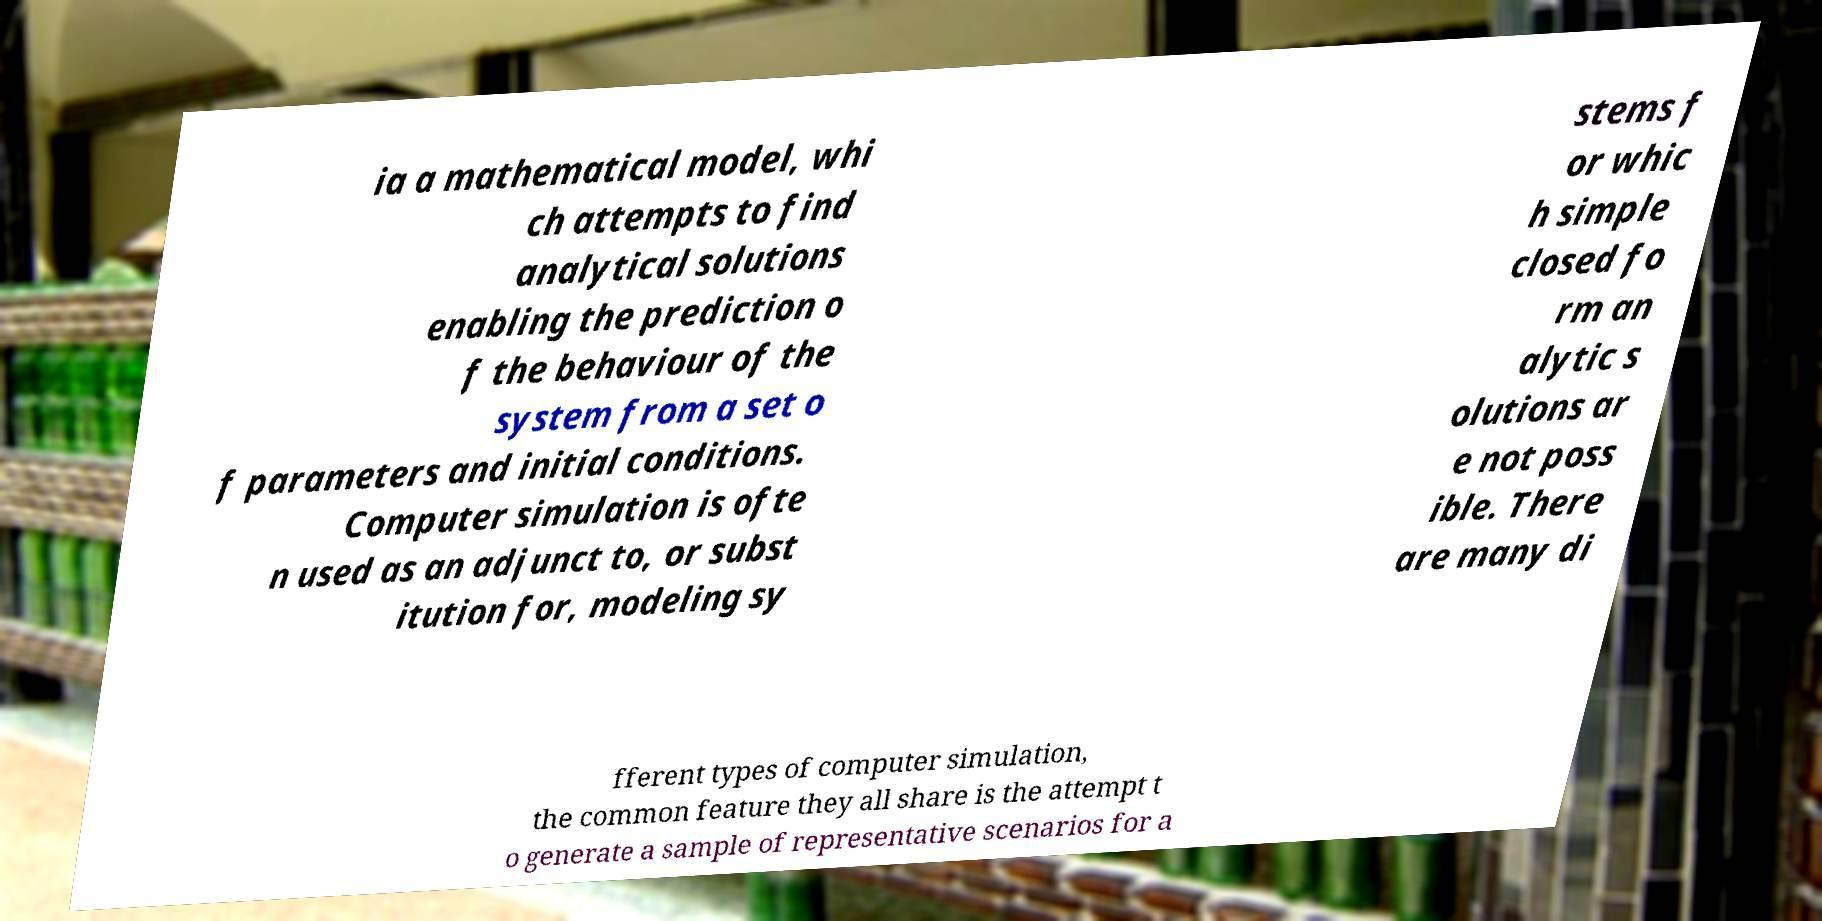Could you extract and type out the text from this image? ia a mathematical model, whi ch attempts to find analytical solutions enabling the prediction o f the behaviour of the system from a set o f parameters and initial conditions. Computer simulation is ofte n used as an adjunct to, or subst itution for, modeling sy stems f or whic h simple closed fo rm an alytic s olutions ar e not poss ible. There are many di fferent types of computer simulation, the common feature they all share is the attempt t o generate a sample of representative scenarios for a 